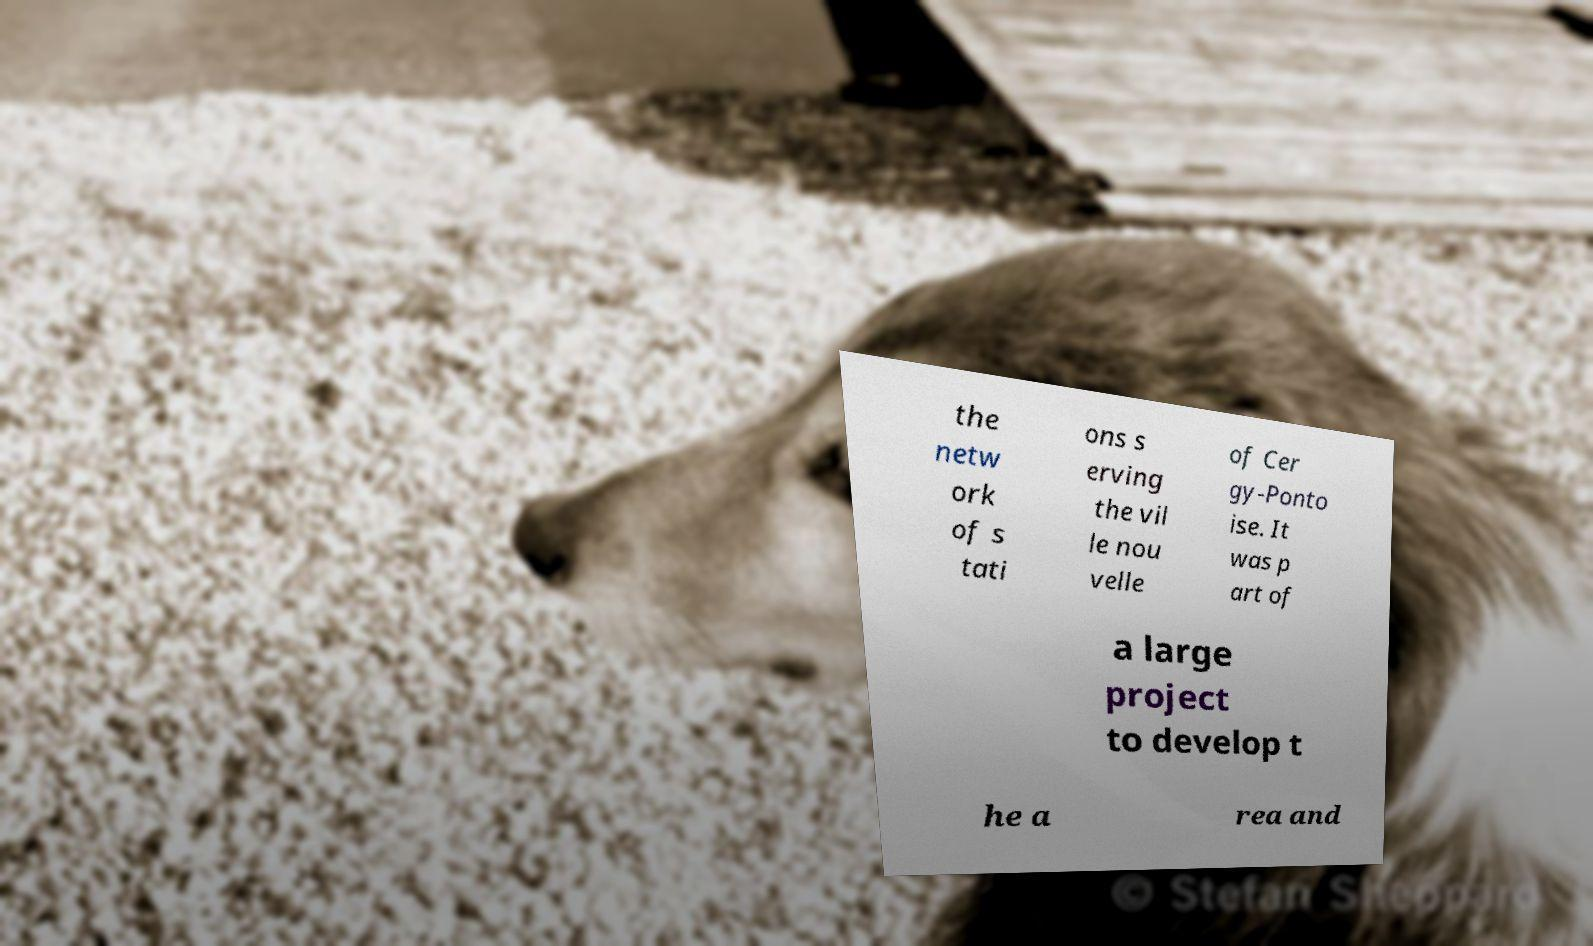There's text embedded in this image that I need extracted. Can you transcribe it verbatim? the netw ork of s tati ons s erving the vil le nou velle of Cer gy-Ponto ise. It was p art of a large project to develop t he a rea and 